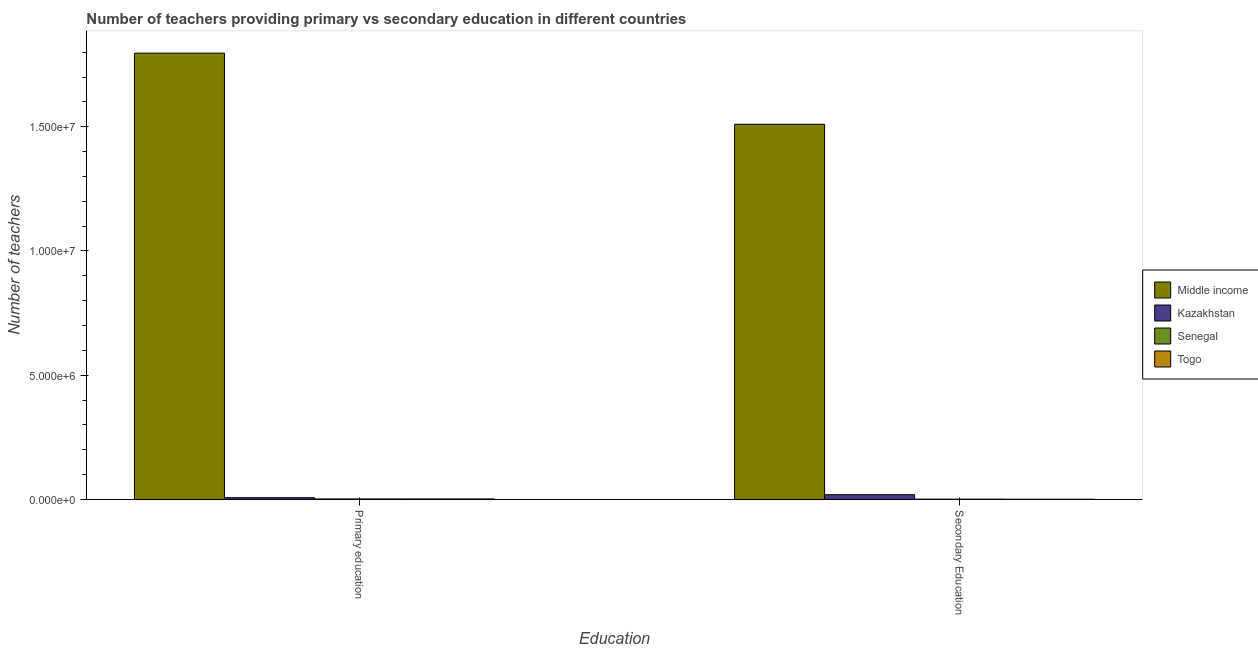Are the number of bars per tick equal to the number of legend labels?
Give a very brief answer. Yes. Are the number of bars on each tick of the X-axis equal?
Give a very brief answer. Yes. What is the number of secondary teachers in Middle income?
Provide a succinct answer. 1.51e+07. Across all countries, what is the maximum number of primary teachers?
Your answer should be very brief. 1.80e+07. Across all countries, what is the minimum number of primary teachers?
Offer a terse response. 1.84e+04. In which country was the number of secondary teachers minimum?
Your answer should be very brief. Togo. What is the total number of primary teachers in the graph?
Provide a succinct answer. 1.81e+07. What is the difference between the number of primary teachers in Senegal and that in Togo?
Your answer should be very brief. -1139. What is the difference between the number of secondary teachers in Senegal and the number of primary teachers in Middle income?
Ensure brevity in your answer.  -1.80e+07. What is the average number of primary teachers per country?
Offer a terse response. 4.52e+06. What is the difference between the number of primary teachers and number of secondary teachers in Middle income?
Your response must be concise. 2.86e+06. What is the ratio of the number of secondary teachers in Kazakhstan to that in Middle income?
Your answer should be compact. 0.01. What does the 1st bar from the left in Secondary Education represents?
Your response must be concise. Middle income. What does the 1st bar from the right in Secondary Education represents?
Keep it short and to the point. Togo. What is the difference between two consecutive major ticks on the Y-axis?
Provide a succinct answer. 5.00e+06. Are the values on the major ticks of Y-axis written in scientific E-notation?
Offer a very short reply. Yes. How many legend labels are there?
Offer a very short reply. 4. What is the title of the graph?
Your answer should be compact. Number of teachers providing primary vs secondary education in different countries. Does "Monaco" appear as one of the legend labels in the graph?
Provide a short and direct response. No. What is the label or title of the X-axis?
Your answer should be very brief. Education. What is the label or title of the Y-axis?
Give a very brief answer. Number of teachers. What is the Number of teachers in Middle income in Primary education?
Provide a succinct answer. 1.80e+07. What is the Number of teachers of Kazakhstan in Primary education?
Your response must be concise. 7.04e+04. What is the Number of teachers in Senegal in Primary education?
Ensure brevity in your answer.  1.84e+04. What is the Number of teachers of Togo in Primary education?
Offer a terse response. 1.95e+04. What is the Number of teachers of Middle income in Secondary Education?
Offer a terse response. 1.51e+07. What is the Number of teachers of Kazakhstan in Secondary Education?
Offer a very short reply. 1.90e+05. What is the Number of teachers of Senegal in Secondary Education?
Offer a very short reply. 9055. What is the Number of teachers in Togo in Secondary Education?
Your response must be concise. 5962. Across all Education, what is the maximum Number of teachers in Middle income?
Make the answer very short. 1.80e+07. Across all Education, what is the maximum Number of teachers in Kazakhstan?
Offer a very short reply. 1.90e+05. Across all Education, what is the maximum Number of teachers in Senegal?
Make the answer very short. 1.84e+04. Across all Education, what is the maximum Number of teachers of Togo?
Ensure brevity in your answer.  1.95e+04. Across all Education, what is the minimum Number of teachers of Middle income?
Ensure brevity in your answer.  1.51e+07. Across all Education, what is the minimum Number of teachers of Kazakhstan?
Your response must be concise. 7.04e+04. Across all Education, what is the minimum Number of teachers of Senegal?
Offer a terse response. 9055. Across all Education, what is the minimum Number of teachers in Togo?
Make the answer very short. 5962. What is the total Number of teachers in Middle income in the graph?
Provide a succinct answer. 3.31e+07. What is the total Number of teachers of Kazakhstan in the graph?
Keep it short and to the point. 2.61e+05. What is the total Number of teachers in Senegal in the graph?
Offer a terse response. 2.74e+04. What is the total Number of teachers in Togo in the graph?
Offer a very short reply. 2.55e+04. What is the difference between the Number of teachers of Middle income in Primary education and that in Secondary Education?
Ensure brevity in your answer.  2.86e+06. What is the difference between the Number of teachers of Kazakhstan in Primary education and that in Secondary Education?
Your response must be concise. -1.20e+05. What is the difference between the Number of teachers of Senegal in Primary education and that in Secondary Education?
Provide a succinct answer. 9318. What is the difference between the Number of teachers in Togo in Primary education and that in Secondary Education?
Offer a terse response. 1.36e+04. What is the difference between the Number of teachers of Middle income in Primary education and the Number of teachers of Kazakhstan in Secondary Education?
Offer a very short reply. 1.78e+07. What is the difference between the Number of teachers in Middle income in Primary education and the Number of teachers in Senegal in Secondary Education?
Keep it short and to the point. 1.80e+07. What is the difference between the Number of teachers in Middle income in Primary education and the Number of teachers in Togo in Secondary Education?
Give a very brief answer. 1.80e+07. What is the difference between the Number of teachers in Kazakhstan in Primary education and the Number of teachers in Senegal in Secondary Education?
Keep it short and to the point. 6.13e+04. What is the difference between the Number of teachers in Kazakhstan in Primary education and the Number of teachers in Togo in Secondary Education?
Your answer should be compact. 6.44e+04. What is the difference between the Number of teachers of Senegal in Primary education and the Number of teachers of Togo in Secondary Education?
Provide a short and direct response. 1.24e+04. What is the average Number of teachers of Middle income per Education?
Provide a succinct answer. 1.65e+07. What is the average Number of teachers in Kazakhstan per Education?
Ensure brevity in your answer.  1.30e+05. What is the average Number of teachers in Senegal per Education?
Your response must be concise. 1.37e+04. What is the average Number of teachers in Togo per Education?
Provide a short and direct response. 1.27e+04. What is the difference between the Number of teachers of Middle income and Number of teachers of Kazakhstan in Primary education?
Make the answer very short. 1.79e+07. What is the difference between the Number of teachers of Middle income and Number of teachers of Senegal in Primary education?
Your response must be concise. 1.79e+07. What is the difference between the Number of teachers in Middle income and Number of teachers in Togo in Primary education?
Keep it short and to the point. 1.79e+07. What is the difference between the Number of teachers in Kazakhstan and Number of teachers in Senegal in Primary education?
Offer a very short reply. 5.20e+04. What is the difference between the Number of teachers in Kazakhstan and Number of teachers in Togo in Primary education?
Your answer should be compact. 5.09e+04. What is the difference between the Number of teachers of Senegal and Number of teachers of Togo in Primary education?
Offer a very short reply. -1139. What is the difference between the Number of teachers of Middle income and Number of teachers of Kazakhstan in Secondary Education?
Your answer should be very brief. 1.49e+07. What is the difference between the Number of teachers of Middle income and Number of teachers of Senegal in Secondary Education?
Your answer should be very brief. 1.51e+07. What is the difference between the Number of teachers of Middle income and Number of teachers of Togo in Secondary Education?
Your answer should be very brief. 1.51e+07. What is the difference between the Number of teachers of Kazakhstan and Number of teachers of Senegal in Secondary Education?
Offer a terse response. 1.81e+05. What is the difference between the Number of teachers in Kazakhstan and Number of teachers in Togo in Secondary Education?
Your answer should be very brief. 1.84e+05. What is the difference between the Number of teachers of Senegal and Number of teachers of Togo in Secondary Education?
Offer a very short reply. 3093. What is the ratio of the Number of teachers in Middle income in Primary education to that in Secondary Education?
Provide a short and direct response. 1.19. What is the ratio of the Number of teachers in Kazakhstan in Primary education to that in Secondary Education?
Your answer should be very brief. 0.37. What is the ratio of the Number of teachers in Senegal in Primary education to that in Secondary Education?
Give a very brief answer. 2.03. What is the ratio of the Number of teachers of Togo in Primary education to that in Secondary Education?
Your answer should be compact. 3.27. What is the difference between the highest and the second highest Number of teachers of Middle income?
Provide a succinct answer. 2.86e+06. What is the difference between the highest and the second highest Number of teachers in Kazakhstan?
Offer a very short reply. 1.20e+05. What is the difference between the highest and the second highest Number of teachers in Senegal?
Your response must be concise. 9318. What is the difference between the highest and the second highest Number of teachers in Togo?
Provide a succinct answer. 1.36e+04. What is the difference between the highest and the lowest Number of teachers in Middle income?
Make the answer very short. 2.86e+06. What is the difference between the highest and the lowest Number of teachers in Kazakhstan?
Provide a short and direct response. 1.20e+05. What is the difference between the highest and the lowest Number of teachers of Senegal?
Provide a succinct answer. 9318. What is the difference between the highest and the lowest Number of teachers of Togo?
Provide a succinct answer. 1.36e+04. 